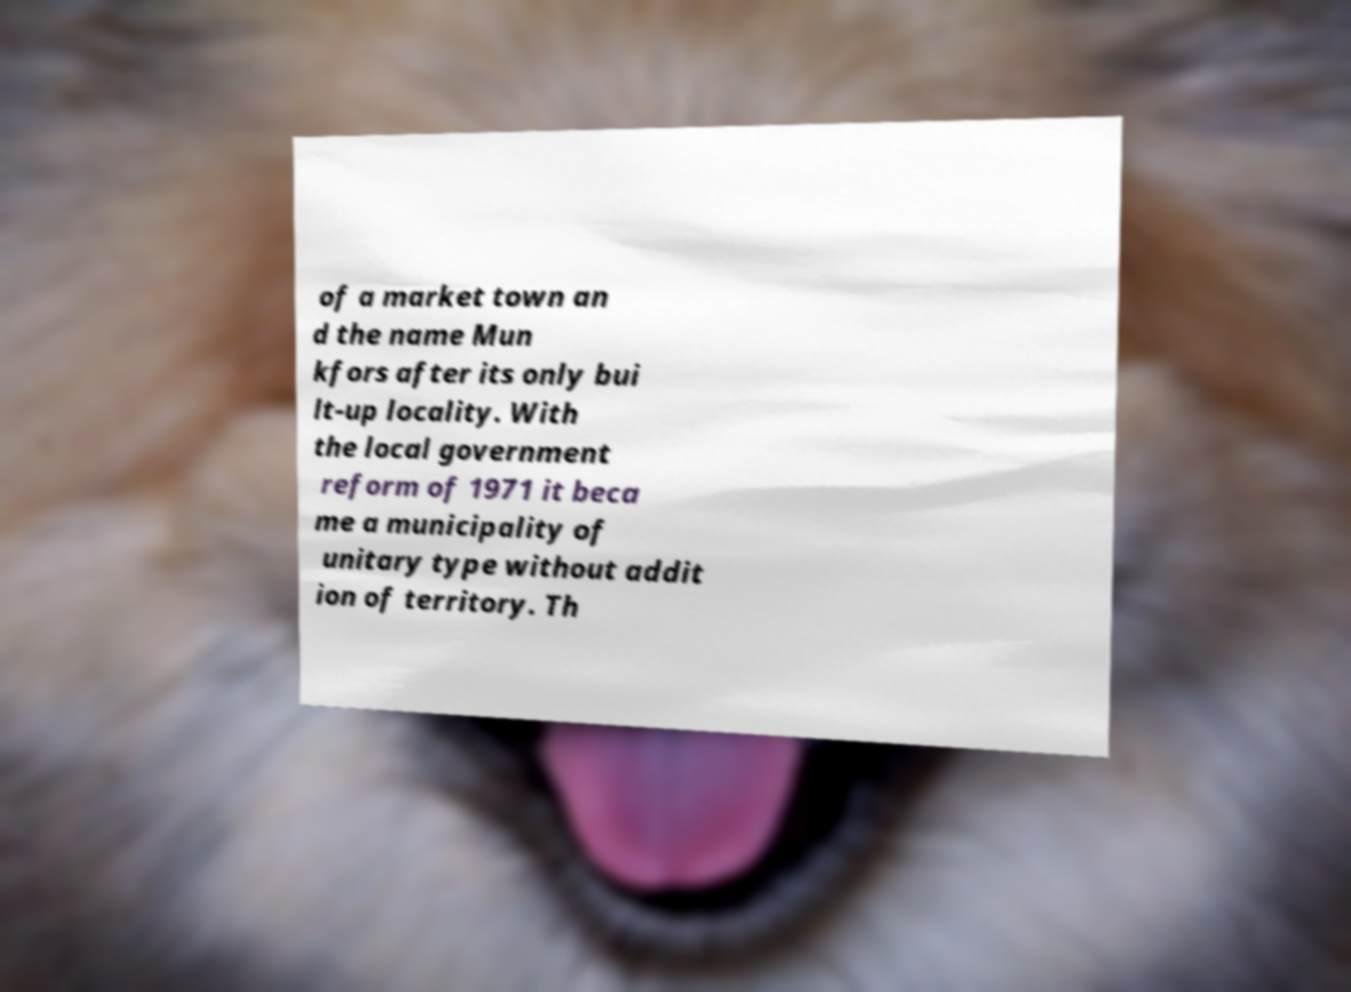Can you accurately transcribe the text from the provided image for me? of a market town an d the name Mun kfors after its only bui lt-up locality. With the local government reform of 1971 it beca me a municipality of unitary type without addit ion of territory. Th 